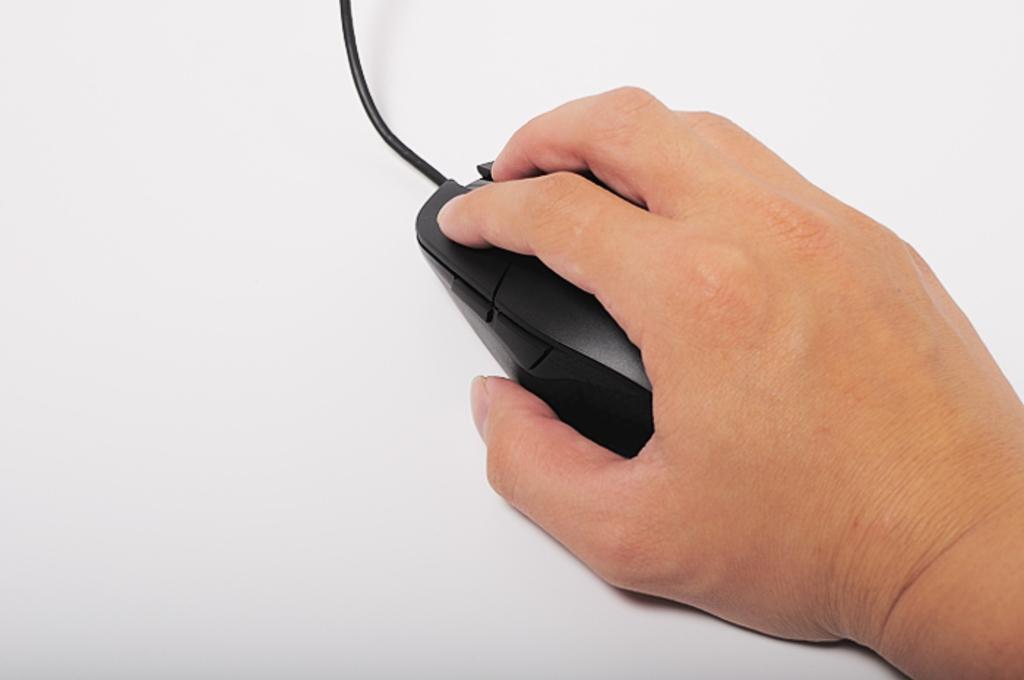Describe this image in one or two sentences. On the right of this picture we can see the hand of a person holding the mouse. In the background we can see a cable and a white color object which seems to be the table. 